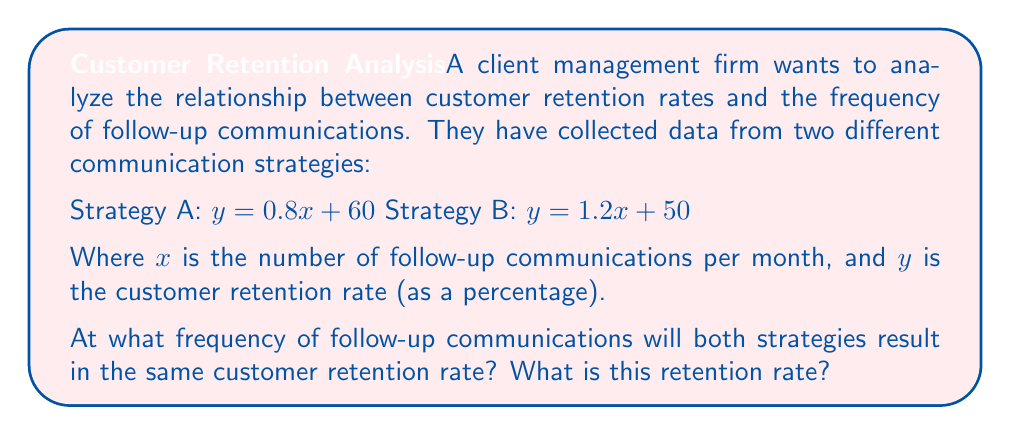Teach me how to tackle this problem. To solve this problem, we need to find the point of intersection between the two linear equations representing the strategies. This can be done by setting the equations equal to each other and solving for $x$.

1. Set the equations equal:
   $0.8x + 60 = 1.2x + 50$

2. Subtract $0.8x$ from both sides:
   $60 = 0.4x + 50$

3. Subtract 50 from both sides:
   $10 = 0.4x$

4. Divide both sides by 0.4:
   $\frac{10}{0.4} = x$
   $25 = x$

5. Now that we know the $x$ value (frequency of follow-up communications), we can substitute it into either equation to find the $y$ value (retention rate):

   Using Strategy A: $y = 0.8(25) + 60 = 20 + 60 = 80$

   We can verify this using Strategy B:
   $y = 1.2(25) + 50 = 30 + 50 = 80$

Therefore, both strategies will result in the same customer retention rate when the frequency of follow-up communications is 25 per month, and the retention rate at this point is 80%.
Answer: The strategies result in the same customer retention rate at 25 follow-up communications per month, with a retention rate of 80%. 